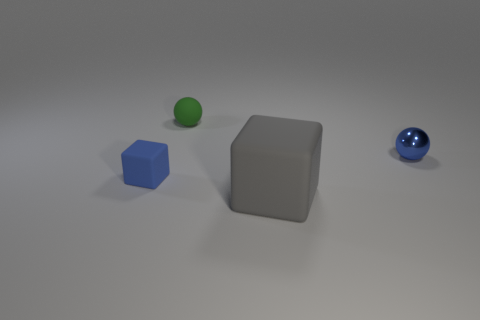There is a ball that is the same color as the small cube; what is its material?
Give a very brief answer. Metal. There is a tiny sphere that is on the left side of the matte object that is in front of the small block; what is it made of?
Provide a short and direct response. Rubber. There is a blue object that is the same shape as the gray object; what is its size?
Keep it short and to the point. Small. Is the number of tiny purple shiny spheres the same as the number of tiny blue metal things?
Provide a short and direct response. No. There is a rubber cube in front of the blue rubber block; is its color the same as the tiny matte sphere?
Give a very brief answer. No. Is the number of tiny yellow matte spheres less than the number of blue objects?
Your answer should be very brief. Yes. What number of other things are there of the same color as the big rubber cube?
Your answer should be very brief. 0. Are the blue thing that is to the left of the large gray matte cube and the big block made of the same material?
Offer a very short reply. Yes. There is a blue object on the left side of the gray rubber block; what material is it?
Make the answer very short. Rubber. What is the size of the blue object behind the cube behind the gray thing?
Your answer should be very brief. Small. 